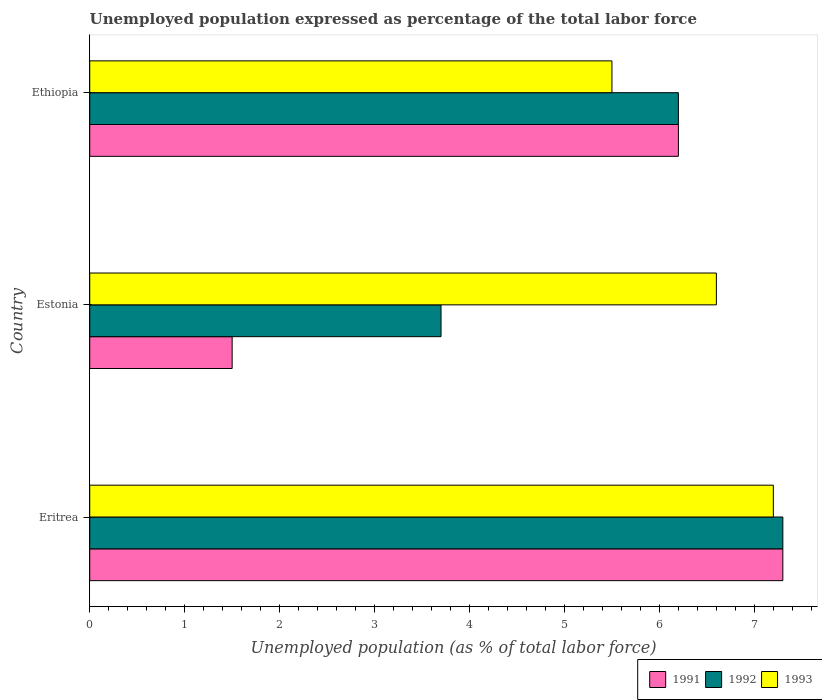How many different coloured bars are there?
Provide a short and direct response. 3. Are the number of bars per tick equal to the number of legend labels?
Ensure brevity in your answer.  Yes. How many bars are there on the 1st tick from the top?
Provide a short and direct response. 3. How many bars are there on the 2nd tick from the bottom?
Keep it short and to the point. 3. What is the label of the 3rd group of bars from the top?
Make the answer very short. Eritrea. In how many cases, is the number of bars for a given country not equal to the number of legend labels?
Make the answer very short. 0. What is the unemployment in in 1993 in Ethiopia?
Give a very brief answer. 5.5. Across all countries, what is the maximum unemployment in in 1993?
Ensure brevity in your answer.  7.2. Across all countries, what is the minimum unemployment in in 1992?
Offer a terse response. 3.7. In which country was the unemployment in in 1993 maximum?
Your answer should be compact. Eritrea. In which country was the unemployment in in 1993 minimum?
Make the answer very short. Ethiopia. What is the total unemployment in in 1993 in the graph?
Offer a terse response. 19.3. What is the difference between the unemployment in in 1993 in Estonia and that in Ethiopia?
Your answer should be very brief. 1.1. What is the average unemployment in in 1993 per country?
Keep it short and to the point. 6.43. What is the difference between the unemployment in in 1993 and unemployment in in 1992 in Eritrea?
Offer a terse response. -0.1. What is the ratio of the unemployment in in 1993 in Eritrea to that in Estonia?
Provide a short and direct response. 1.09. Is the difference between the unemployment in in 1993 in Eritrea and Estonia greater than the difference between the unemployment in in 1992 in Eritrea and Estonia?
Offer a very short reply. No. What is the difference between the highest and the second highest unemployment in in 1991?
Your answer should be compact. 1.1. What is the difference between the highest and the lowest unemployment in in 1992?
Your answer should be compact. 3.6. What does the 1st bar from the top in Eritrea represents?
Offer a terse response. 1993. What does the 2nd bar from the bottom in Eritrea represents?
Your answer should be very brief. 1992. Are the values on the major ticks of X-axis written in scientific E-notation?
Provide a short and direct response. No. Does the graph contain any zero values?
Make the answer very short. No. Does the graph contain grids?
Your response must be concise. No. How many legend labels are there?
Ensure brevity in your answer.  3. How are the legend labels stacked?
Provide a succinct answer. Horizontal. What is the title of the graph?
Your response must be concise. Unemployed population expressed as percentage of the total labor force. Does "1967" appear as one of the legend labels in the graph?
Offer a very short reply. No. What is the label or title of the X-axis?
Give a very brief answer. Unemployed population (as % of total labor force). What is the label or title of the Y-axis?
Offer a terse response. Country. What is the Unemployed population (as % of total labor force) in 1991 in Eritrea?
Make the answer very short. 7.3. What is the Unemployed population (as % of total labor force) in 1992 in Eritrea?
Your answer should be compact. 7.3. What is the Unemployed population (as % of total labor force) in 1993 in Eritrea?
Your response must be concise. 7.2. What is the Unemployed population (as % of total labor force) of 1992 in Estonia?
Provide a short and direct response. 3.7. What is the Unemployed population (as % of total labor force) in 1993 in Estonia?
Provide a succinct answer. 6.6. What is the Unemployed population (as % of total labor force) of 1991 in Ethiopia?
Keep it short and to the point. 6.2. What is the Unemployed population (as % of total labor force) in 1992 in Ethiopia?
Provide a short and direct response. 6.2. What is the Unemployed population (as % of total labor force) of 1993 in Ethiopia?
Ensure brevity in your answer.  5.5. Across all countries, what is the maximum Unemployed population (as % of total labor force) in 1991?
Keep it short and to the point. 7.3. Across all countries, what is the maximum Unemployed population (as % of total labor force) in 1992?
Your answer should be very brief. 7.3. Across all countries, what is the maximum Unemployed population (as % of total labor force) of 1993?
Offer a very short reply. 7.2. Across all countries, what is the minimum Unemployed population (as % of total labor force) in 1991?
Make the answer very short. 1.5. Across all countries, what is the minimum Unemployed population (as % of total labor force) in 1992?
Your answer should be very brief. 3.7. What is the total Unemployed population (as % of total labor force) in 1991 in the graph?
Give a very brief answer. 15. What is the total Unemployed population (as % of total labor force) in 1992 in the graph?
Offer a very short reply. 17.2. What is the total Unemployed population (as % of total labor force) of 1993 in the graph?
Provide a succinct answer. 19.3. What is the difference between the Unemployed population (as % of total labor force) of 1991 in Eritrea and that in Ethiopia?
Offer a terse response. 1.1. What is the difference between the Unemployed population (as % of total labor force) of 1992 in Eritrea and that in Ethiopia?
Your answer should be very brief. 1.1. What is the difference between the Unemployed population (as % of total labor force) of 1993 in Eritrea and that in Ethiopia?
Your answer should be very brief. 1.7. What is the difference between the Unemployed population (as % of total labor force) of 1993 in Estonia and that in Ethiopia?
Give a very brief answer. 1.1. What is the difference between the Unemployed population (as % of total labor force) in 1992 in Eritrea and the Unemployed population (as % of total labor force) in 1993 in Estonia?
Give a very brief answer. 0.7. What is the difference between the Unemployed population (as % of total labor force) in 1991 in Estonia and the Unemployed population (as % of total labor force) in 1992 in Ethiopia?
Offer a very short reply. -4.7. What is the difference between the Unemployed population (as % of total labor force) of 1991 in Estonia and the Unemployed population (as % of total labor force) of 1993 in Ethiopia?
Offer a very short reply. -4. What is the difference between the Unemployed population (as % of total labor force) in 1992 in Estonia and the Unemployed population (as % of total labor force) in 1993 in Ethiopia?
Your response must be concise. -1.8. What is the average Unemployed population (as % of total labor force) of 1991 per country?
Provide a succinct answer. 5. What is the average Unemployed population (as % of total labor force) of 1992 per country?
Provide a short and direct response. 5.73. What is the average Unemployed population (as % of total labor force) of 1993 per country?
Ensure brevity in your answer.  6.43. What is the ratio of the Unemployed population (as % of total labor force) in 1991 in Eritrea to that in Estonia?
Offer a very short reply. 4.87. What is the ratio of the Unemployed population (as % of total labor force) in 1992 in Eritrea to that in Estonia?
Provide a succinct answer. 1.97. What is the ratio of the Unemployed population (as % of total labor force) of 1991 in Eritrea to that in Ethiopia?
Offer a terse response. 1.18. What is the ratio of the Unemployed population (as % of total labor force) in 1992 in Eritrea to that in Ethiopia?
Your answer should be very brief. 1.18. What is the ratio of the Unemployed population (as % of total labor force) of 1993 in Eritrea to that in Ethiopia?
Keep it short and to the point. 1.31. What is the ratio of the Unemployed population (as % of total labor force) in 1991 in Estonia to that in Ethiopia?
Your answer should be very brief. 0.24. What is the ratio of the Unemployed population (as % of total labor force) of 1992 in Estonia to that in Ethiopia?
Your answer should be compact. 0.6. What is the difference between the highest and the second highest Unemployed population (as % of total labor force) of 1993?
Your response must be concise. 0.6. What is the difference between the highest and the lowest Unemployed population (as % of total labor force) in 1991?
Offer a very short reply. 5.8. What is the difference between the highest and the lowest Unemployed population (as % of total labor force) of 1993?
Ensure brevity in your answer.  1.7. 